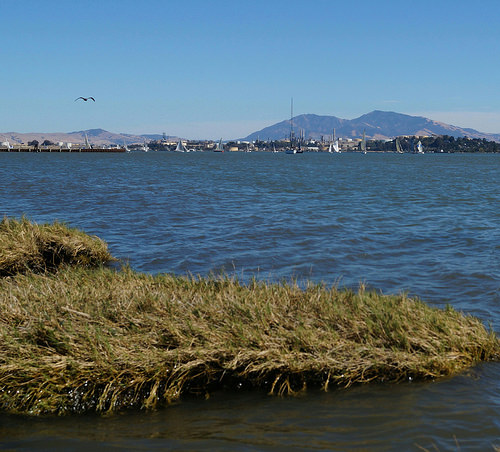<image>
Is there a grass on the water? Yes. Looking at the image, I can see the grass is positioned on top of the water, with the water providing support. 